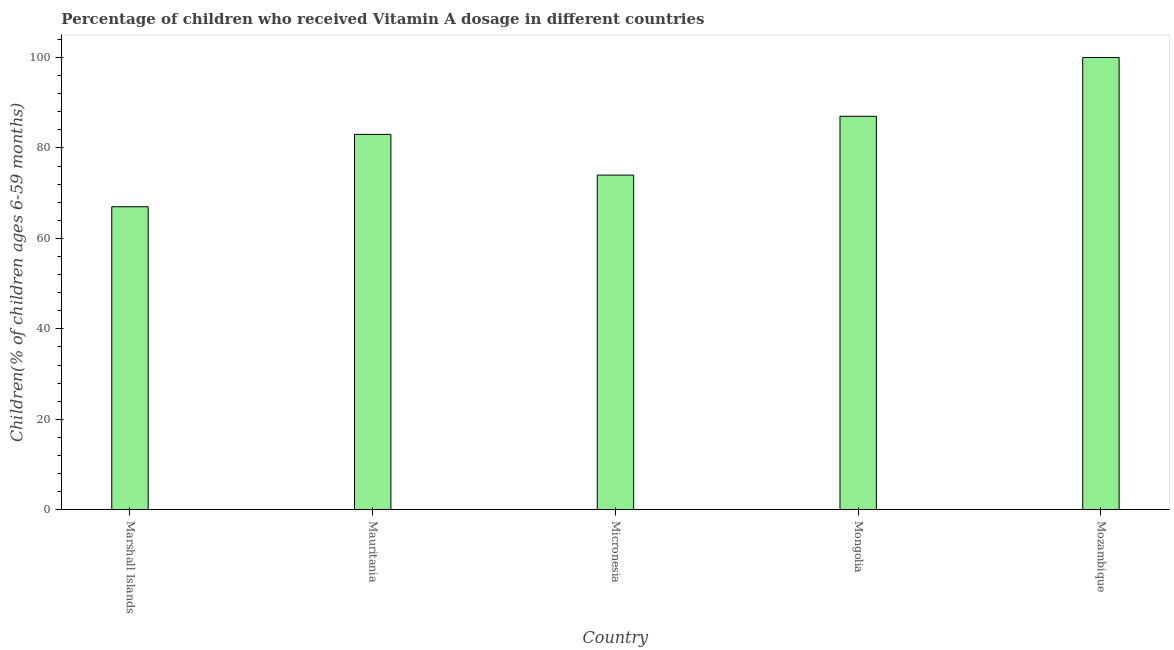What is the title of the graph?
Ensure brevity in your answer.  Percentage of children who received Vitamin A dosage in different countries. What is the label or title of the X-axis?
Offer a very short reply. Country. What is the label or title of the Y-axis?
Your answer should be very brief. Children(% of children ages 6-59 months). Across all countries, what is the maximum vitamin a supplementation coverage rate?
Your response must be concise. 100. Across all countries, what is the minimum vitamin a supplementation coverage rate?
Offer a very short reply. 67. In which country was the vitamin a supplementation coverage rate maximum?
Make the answer very short. Mozambique. In which country was the vitamin a supplementation coverage rate minimum?
Offer a terse response. Marshall Islands. What is the sum of the vitamin a supplementation coverage rate?
Ensure brevity in your answer.  411. What is the average vitamin a supplementation coverage rate per country?
Offer a very short reply. 82.2. What is the median vitamin a supplementation coverage rate?
Your response must be concise. 83. What is the ratio of the vitamin a supplementation coverage rate in Micronesia to that in Mongolia?
Provide a succinct answer. 0.85. Is the sum of the vitamin a supplementation coverage rate in Marshall Islands and Micronesia greater than the maximum vitamin a supplementation coverage rate across all countries?
Your answer should be compact. Yes. What is the difference between the highest and the lowest vitamin a supplementation coverage rate?
Give a very brief answer. 33. How many bars are there?
Provide a succinct answer. 5. What is the difference between two consecutive major ticks on the Y-axis?
Offer a terse response. 20. Are the values on the major ticks of Y-axis written in scientific E-notation?
Keep it short and to the point. No. What is the Children(% of children ages 6-59 months) in Mauritania?
Keep it short and to the point. 83. What is the Children(% of children ages 6-59 months) of Micronesia?
Ensure brevity in your answer.  74. What is the difference between the Children(% of children ages 6-59 months) in Marshall Islands and Mauritania?
Provide a succinct answer. -16. What is the difference between the Children(% of children ages 6-59 months) in Marshall Islands and Mongolia?
Your answer should be compact. -20. What is the difference between the Children(% of children ages 6-59 months) in Marshall Islands and Mozambique?
Your response must be concise. -33. What is the difference between the Children(% of children ages 6-59 months) in Mauritania and Mongolia?
Give a very brief answer. -4. What is the ratio of the Children(% of children ages 6-59 months) in Marshall Islands to that in Mauritania?
Make the answer very short. 0.81. What is the ratio of the Children(% of children ages 6-59 months) in Marshall Islands to that in Micronesia?
Provide a succinct answer. 0.91. What is the ratio of the Children(% of children ages 6-59 months) in Marshall Islands to that in Mongolia?
Your answer should be compact. 0.77. What is the ratio of the Children(% of children ages 6-59 months) in Marshall Islands to that in Mozambique?
Your answer should be very brief. 0.67. What is the ratio of the Children(% of children ages 6-59 months) in Mauritania to that in Micronesia?
Offer a terse response. 1.12. What is the ratio of the Children(% of children ages 6-59 months) in Mauritania to that in Mongolia?
Provide a short and direct response. 0.95. What is the ratio of the Children(% of children ages 6-59 months) in Mauritania to that in Mozambique?
Offer a terse response. 0.83. What is the ratio of the Children(% of children ages 6-59 months) in Micronesia to that in Mongolia?
Offer a very short reply. 0.85. What is the ratio of the Children(% of children ages 6-59 months) in Micronesia to that in Mozambique?
Offer a very short reply. 0.74. What is the ratio of the Children(% of children ages 6-59 months) in Mongolia to that in Mozambique?
Make the answer very short. 0.87. 